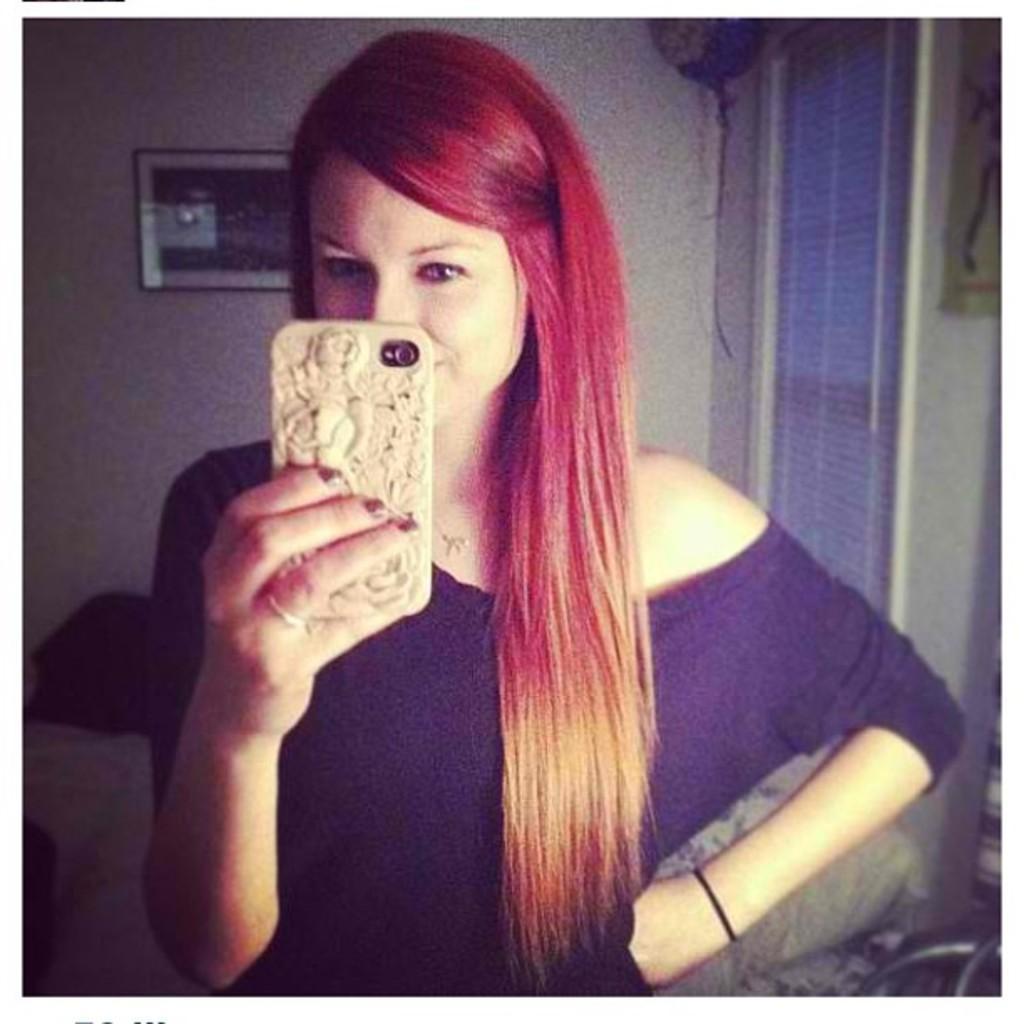Please provide a concise description of this image. In the center of the image we can see a lady standing and holding a mobile. In the background there is a wall and a window. We can see a frame placed on the wall. 